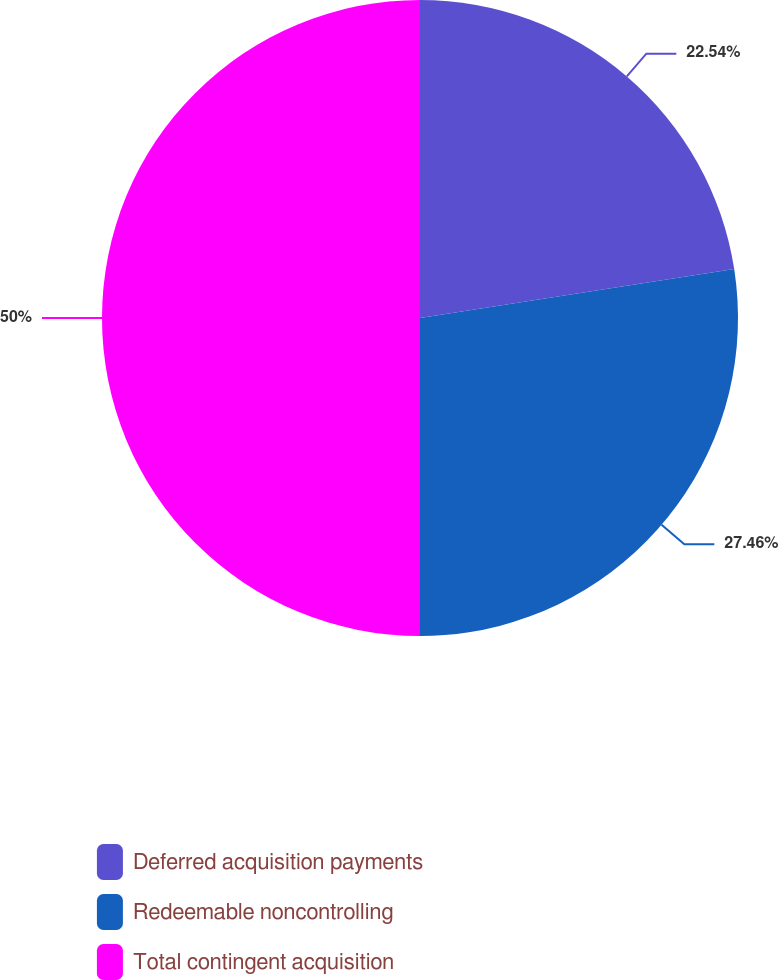<chart> <loc_0><loc_0><loc_500><loc_500><pie_chart><fcel>Deferred acquisition payments<fcel>Redeemable noncontrolling<fcel>Total contingent acquisition<nl><fcel>22.54%<fcel>27.46%<fcel>50.0%<nl></chart> 